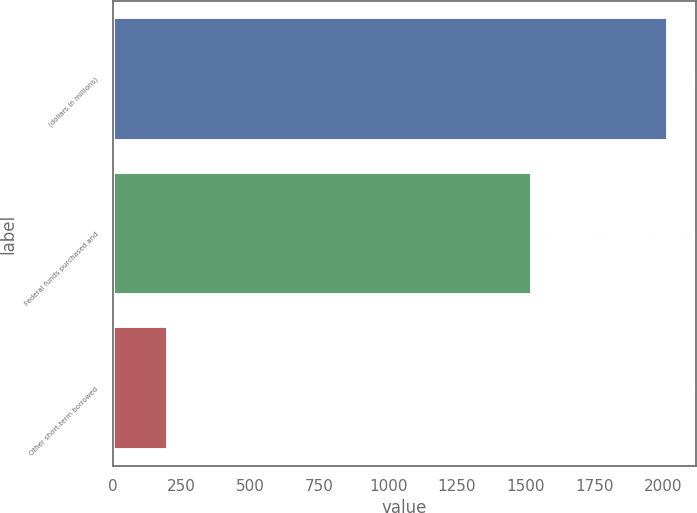Convert chart to OTSL. <chart><loc_0><loc_0><loc_500><loc_500><bar_chart><fcel>(dollars in millions)<fcel>Federal funds purchased and<fcel>Other short-term borrowed<nl><fcel>2016<fcel>1522<fcel>201.83<nl></chart> 